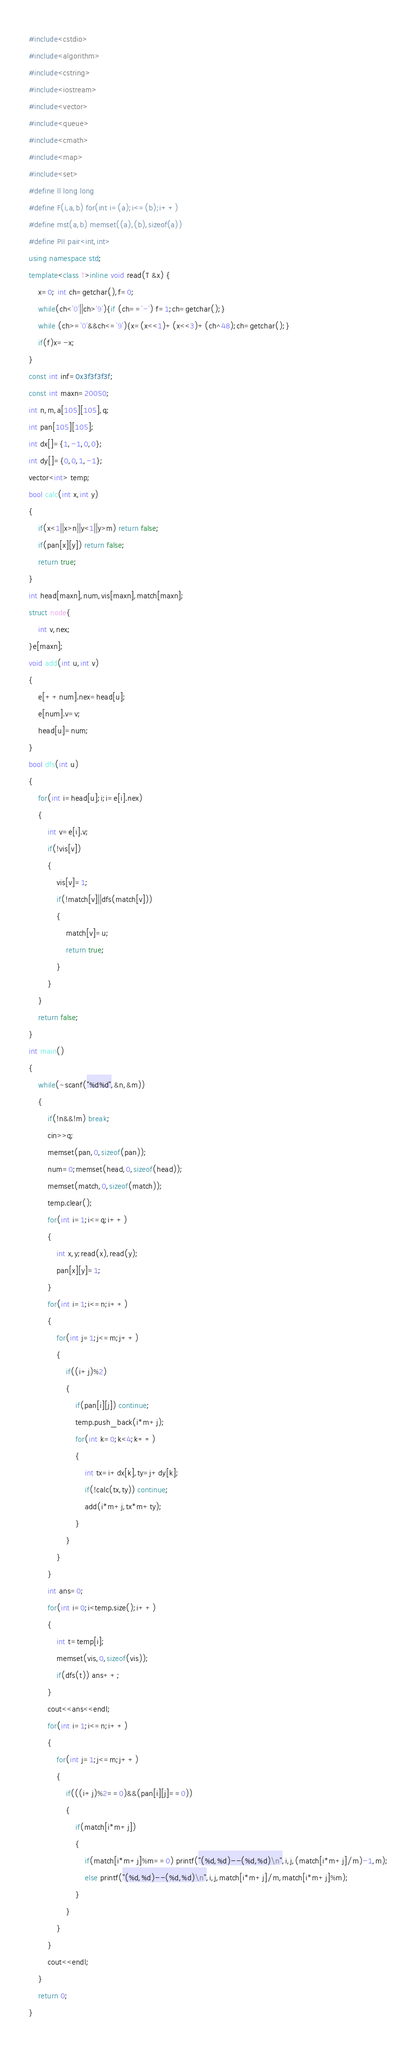Convert code to text. <code><loc_0><loc_0><loc_500><loc_500><_C++_>#include<cstdio>
#include<algorithm>
#include<cstring>
#include<iostream>
#include<vector>
#include<queue>
#include<cmath>
#include<map>
#include<set>
#define ll long long
#define F(i,a,b) for(int i=(a);i<=(b);i++)
#define mst(a,b) memset((a),(b),sizeof(a))
#define PII pair<int,int>
using namespace std;
template<class T>inline void read(T &x) {
    x=0; int ch=getchar(),f=0;
    while(ch<'0'||ch>'9'){if (ch=='-') f=1;ch=getchar();}
    while (ch>='0'&&ch<='9'){x=(x<<1)+(x<<3)+(ch^48);ch=getchar();}
    if(f)x=-x;
}
const int inf=0x3f3f3f3f;
const int maxn=20050;
int n,m,a[105][105],q;
int pan[105][105];
int dx[]={1,-1,0,0};
int dy[]={0,0,1,-1};
vector<int> temp;
bool calc(int x,int y)
{
	if(x<1||x>n||y<1||y>m) return false;
	if(pan[x][y]) return false;
	return true;
}
int head[maxn],num,vis[maxn],match[maxn];
struct node{
	int v,nex;
}e[maxn];
void add(int u,int v)
{
	e[++num].nex=head[u];
	e[num].v=v;
	head[u]=num;
}
bool dfs(int u)
{
	for(int i=head[u];i;i=e[i].nex)
	{
		int v=e[i].v;
		if(!vis[v])
		{
			vis[v]=1;
			if(!match[v]||dfs(match[v]))
			{
				match[v]=u;
				return true;
			}
		}
	}
	return false;
}
int main()
{
	while(~scanf("%d%d",&n,&m))
	{
		if(!n&&!m) break;
		cin>>q;
		memset(pan,0,sizeof(pan));
		num=0;memset(head,0,sizeof(head));
		memset(match,0,sizeof(match));
		temp.clear();
		for(int i=1;i<=q;i++)
		{
			int x,y;read(x),read(y);
			pan[x][y]=1;
		}
		for(int i=1;i<=n;i++)
		{
			for(int j=1;j<=m;j++)
			{
				if((i+j)%2)
				{
					if(pan[i][j]) continue;
					temp.push_back(i*m+j);
					for(int k=0;k<4;k++)
					{
						int tx=i+dx[k],ty=j+dy[k];
						if(!calc(tx,ty)) continue;
						add(i*m+j,tx*m+ty);
					}
				}
			}
		}
		int ans=0;
		for(int i=0;i<temp.size();i++)
		{
			int t=temp[i];
			memset(vis,0,sizeof(vis));
			if(dfs(t)) ans++;
		}
		cout<<ans<<endl;
		for(int i=1;i<=n;i++)
		{
			for(int j=1;j<=m;j++)
			{
				if(((i+j)%2==0)&&(pan[i][j]==0))
				{
					if(match[i*m+j])
					{
						if(match[i*m+j]%m==0) printf("(%d,%d)--(%d,%d)\n",i,j,(match[i*m+j]/m)-1,m);
						else printf("(%d,%d)--(%d,%d)\n",i,j,match[i*m+j]/m,match[i*m+j]%m);
					}
				}
			}
		}
		cout<<endl;
	}
	return 0;
}

</code> 